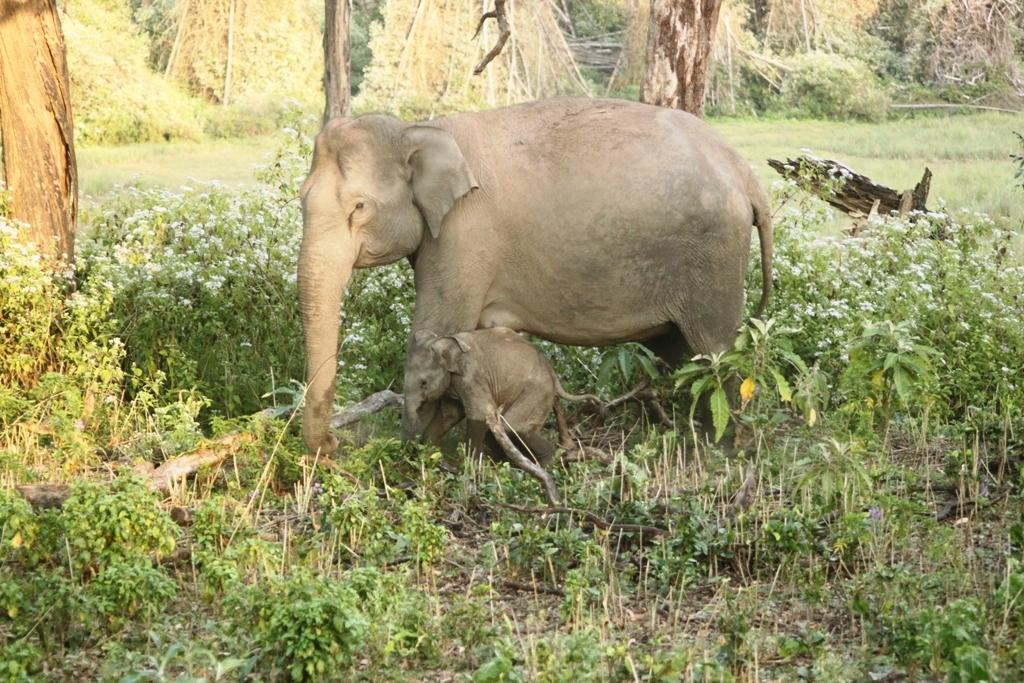What type of animal is in the image? There is an elephant in the image. Is the elephant alone in the image? No, there is a calf with the elephant. What type of vegetation can be seen in the image? There are plants, flowers, and trees in the image. What type of sound can be heard coming from the carriage in the image? There is no carriage present in the image, so it is not possible to determine what sound might be heard. 